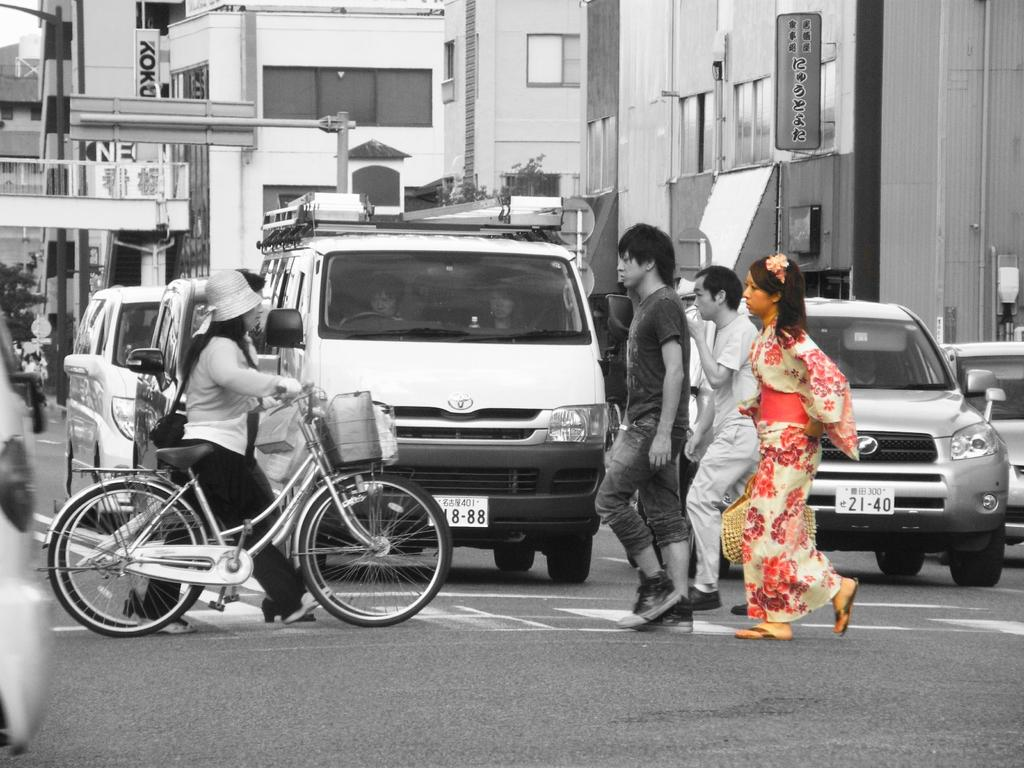What are the people in the image doing? The people in the image are on a path. What else can be seen in the image besides the people? There are vehicles in the image. What can be seen in the distance in the image? There are buildings in the background of the image. What type of cub is playing with an appliance during the rainstorm in the image? There is no cub or appliance present in the image, nor is there a rainstorm depicted. 